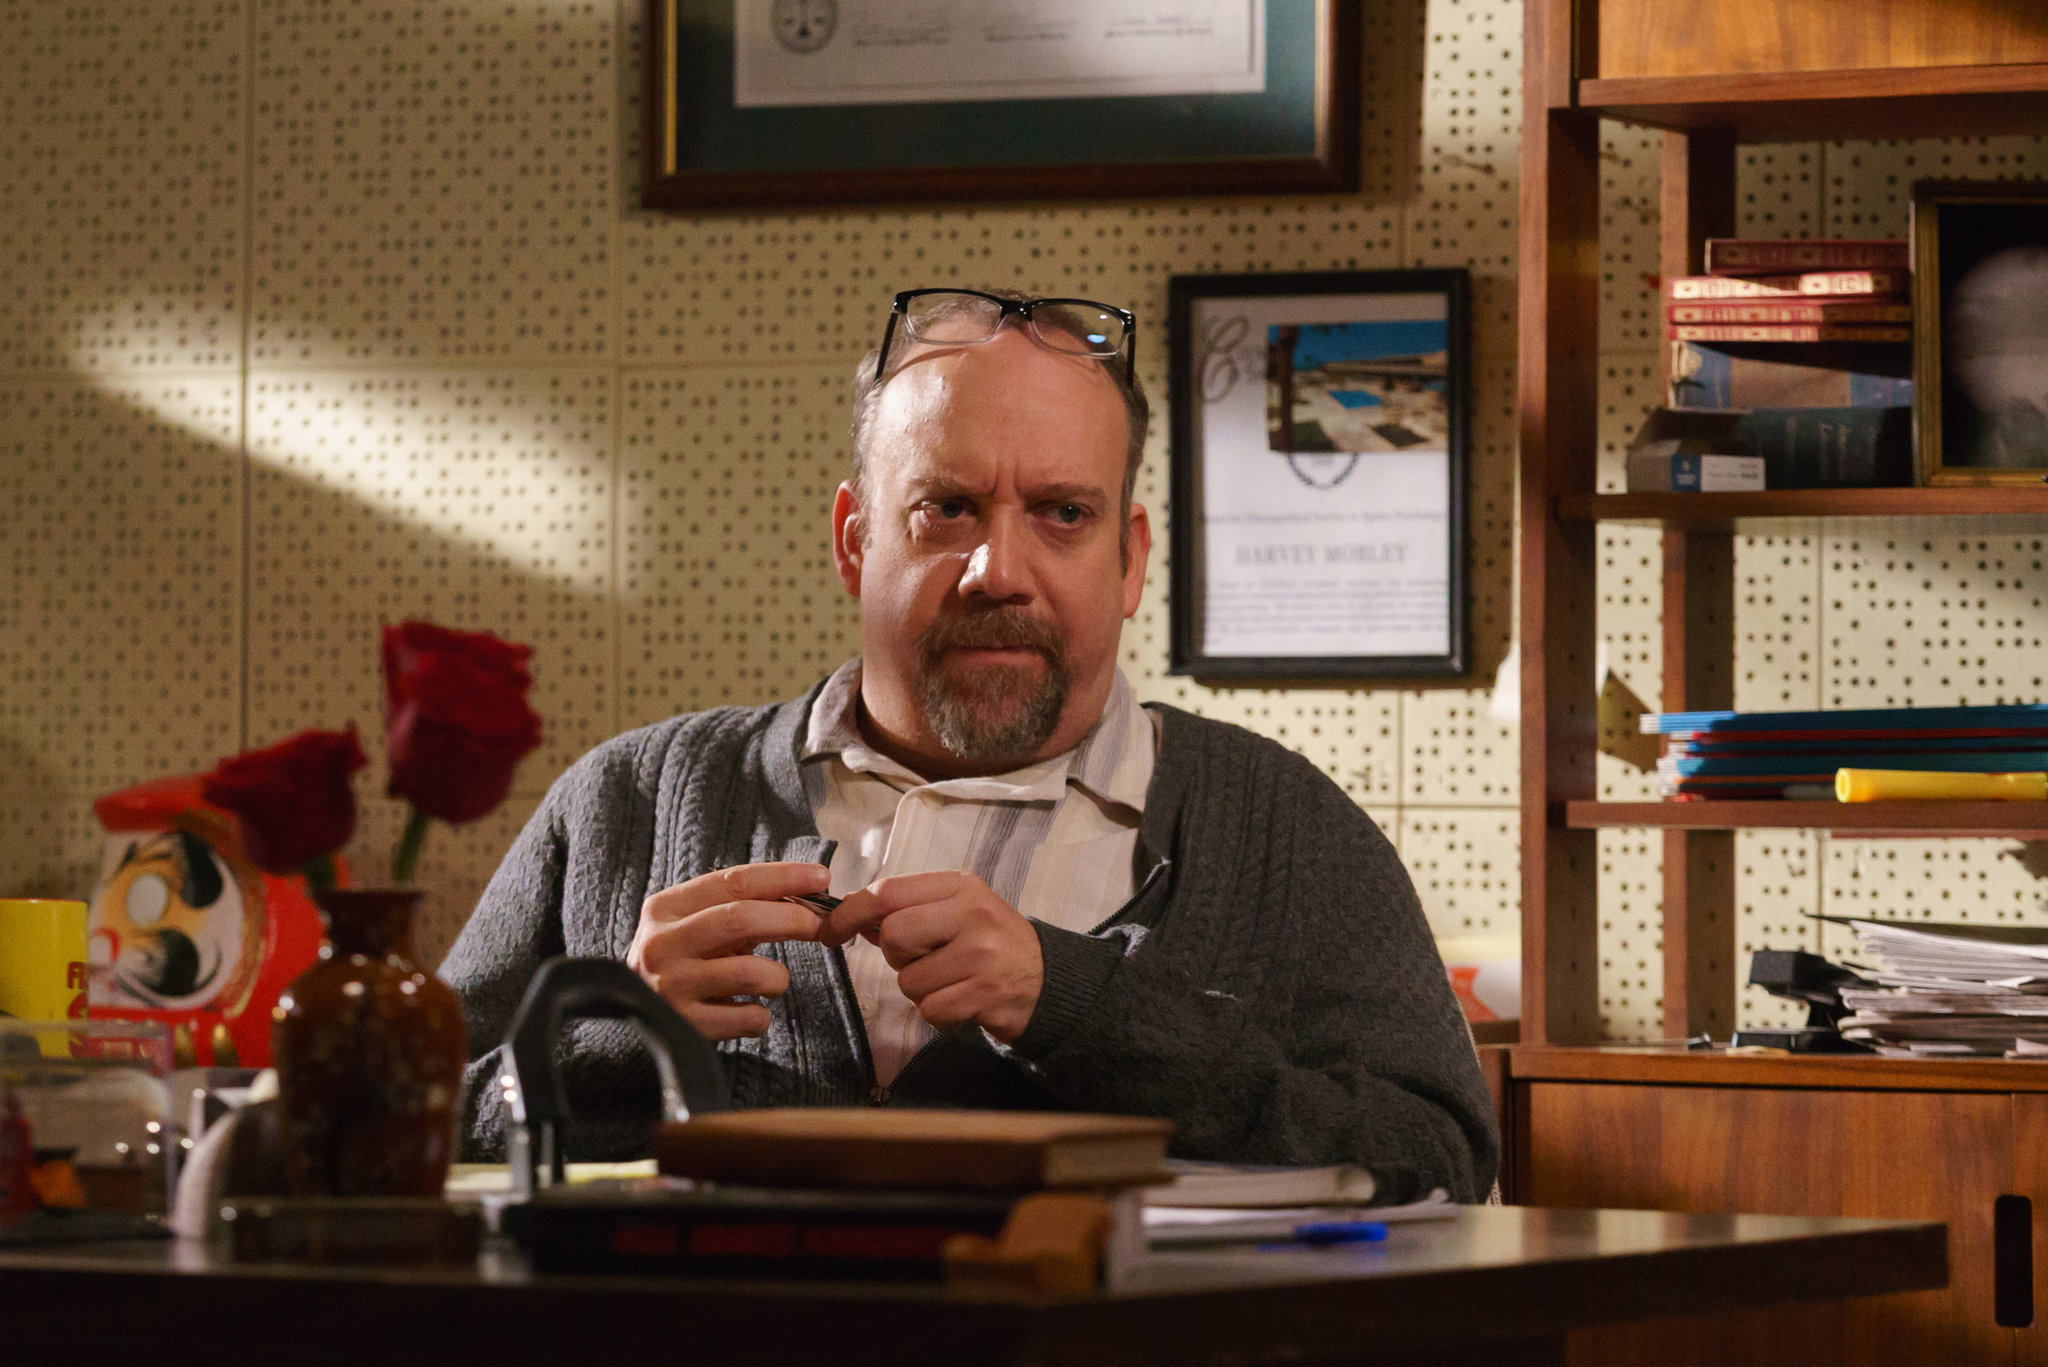Describe a scene where the man receives an unexpected visitor in his office. One rainy afternoon, as the soft patter of raindrops on the window blended with the rustling sound of pages turning, the man was immersed in his work. Suddenly, a sharp knock at the door interrupted his solitude. He looked up, slightly startled, as an unfamiliar young woman stepped into his office. Her coat was drenched, and she clutched a large, leather-bound book to her chest. 'Dr. Thompson?' she inquired hesitantly, her voice barely above a whisper. 'I’m sorry to intrude, but I believe you were acquainted with my grandfather.' The man’s eyes widened in recognition as he motioned for her to sit. The weary, inquisitive look on her face reminded him of himself many years ago. As she handed him the book, revealing ancient symbols on its cover, he realized that the past he had devoted his life to studying was about to unfold in ways he had never imagined. What might be the contents of the mysterious book the visitor brought? The mysterious book the visitor brought contained a wealth of cryptic knowledge, laden with ancient secrets and hidden prophecies. Its leather-bound pages were inscribed with archaic languages and symbols that hinted at a civilization predating known history. Among the esoteric texts, there were detailed maps pointing to uncharted territories and elaborate illustrations of celestial phenomena, suggesting a profound connection between the stars and human destiny. The book also contained personal annotations, possibly left by the visitor’s grandfather, decoding some of the mysteries and linking them to modern scientific discoveries. This treasure trove of information hinted at a truth so monumental that it could reshape the understanding of human history, beckoning Dr. Thompson to embark on a new and perilous journey of discovery. 